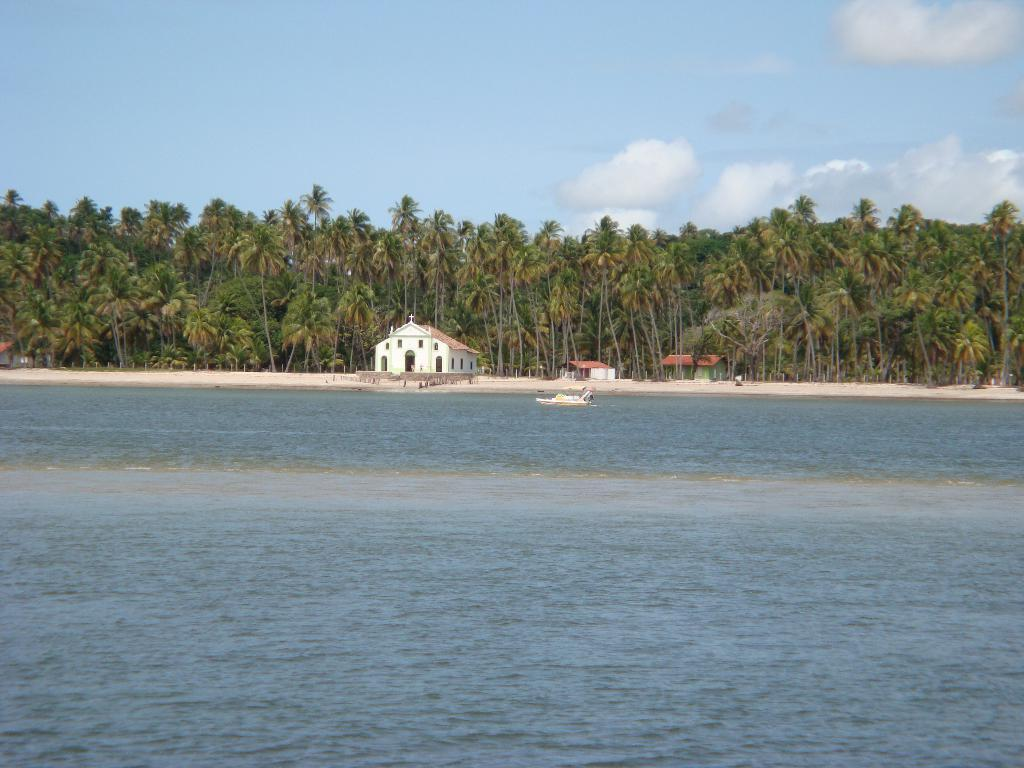What type of natural feature is present in the image? There is a river in the image. What can be seen on the opposite side of the river? On the other side of the river, there are houses and trees. Who is the owner of the fifth house on the other side of the river? There is no information about the number of houses or their owners in the image, so this question cannot be answered definitively. 